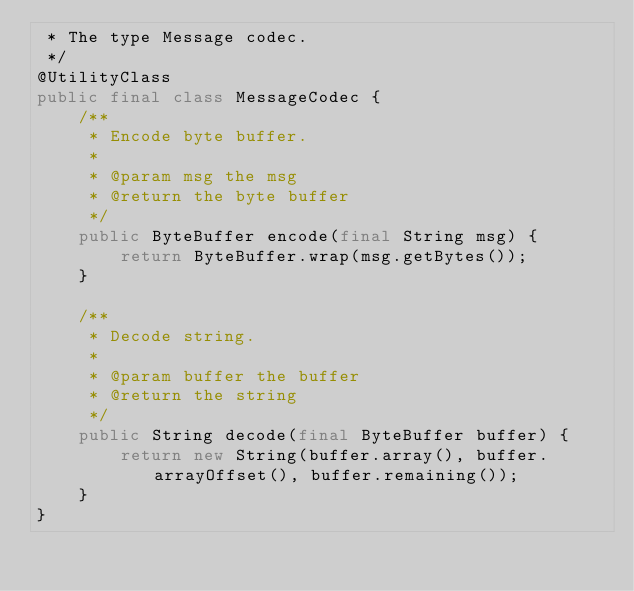<code> <loc_0><loc_0><loc_500><loc_500><_Java_> * The type Message codec.
 */
@UtilityClass
public final class MessageCodec {
    /**
     * Encode byte buffer.
     *
     * @param msg the msg
     * @return the byte buffer
     */
    public ByteBuffer encode(final String msg) {
        return ByteBuffer.wrap(msg.getBytes());
    }

    /**
     * Decode string.
     *
     * @param buffer the buffer
     * @return the string
     */
    public String decode(final ByteBuffer buffer) {
        return new String(buffer.array(), buffer.arrayOffset(), buffer.remaining());
    }
}
</code> 